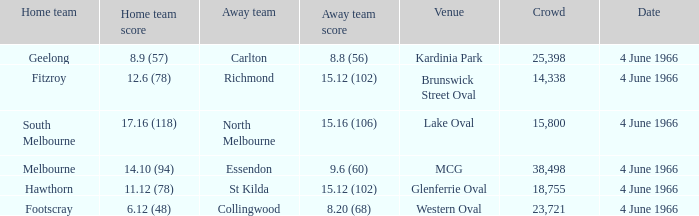What score did the away team achieve when they played against geelong at their home ground? 8.8 (56). 